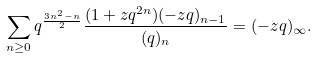<formula> <loc_0><loc_0><loc_500><loc_500>\sum _ { n \geq 0 } q ^ { \frac { 3 n ^ { 2 } - n } { 2 } } \frac { ( 1 + z q ^ { 2 n } ) ( - z q ) _ { n - 1 } } { ( q ) _ { n } } = ( - z q ) _ { \infty } .</formula> 